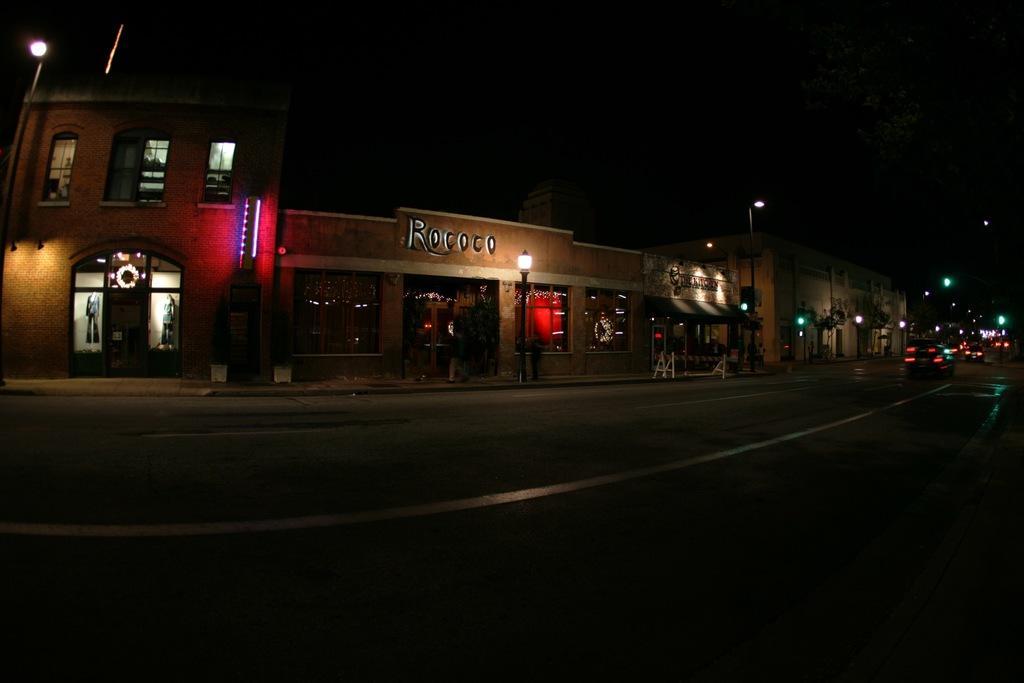Could you give a brief overview of what you see in this image? In this picture we can see a building. In front of the building we can see street lights, benches and ride. On the right we can see many cars which are running on the road. On the top right we can see a dark. 